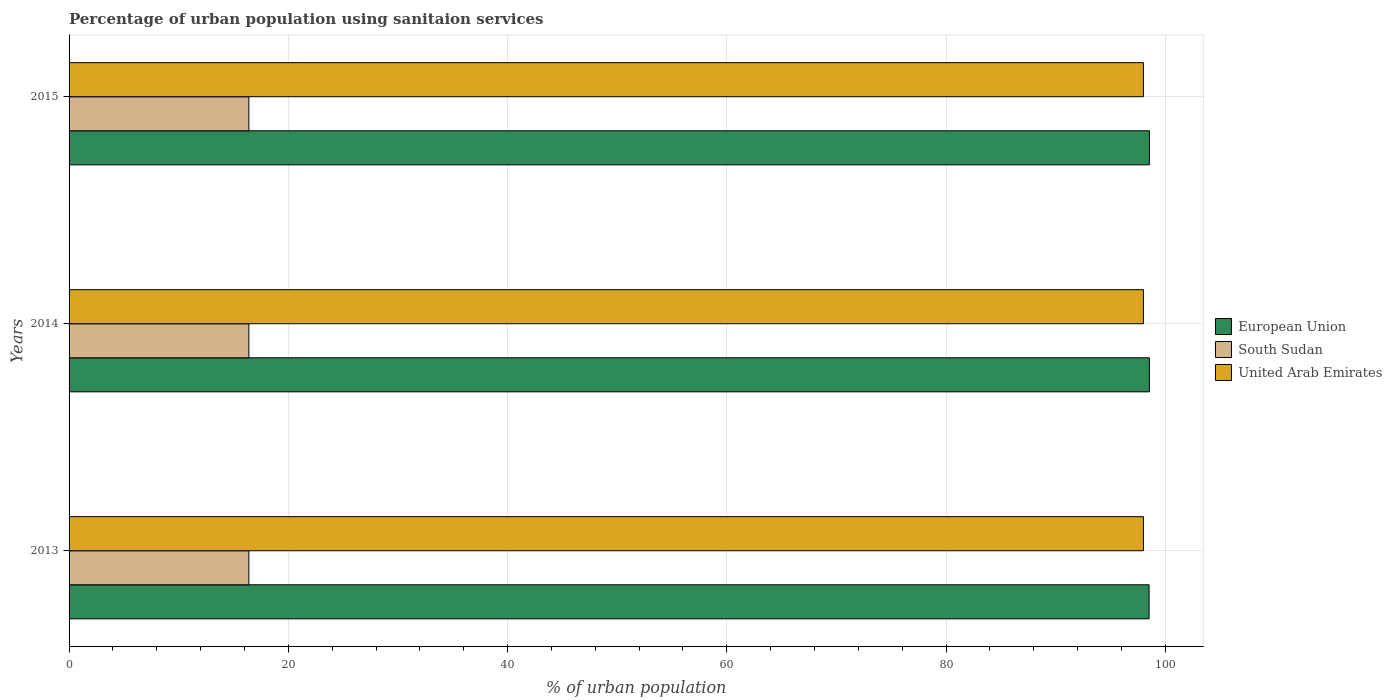Are the number of bars per tick equal to the number of legend labels?
Your answer should be very brief. Yes. Are the number of bars on each tick of the Y-axis equal?
Provide a succinct answer. Yes. What is the label of the 1st group of bars from the top?
Ensure brevity in your answer.  2015. In how many cases, is the number of bars for a given year not equal to the number of legend labels?
Your answer should be very brief. 0. What is the percentage of urban population using sanitaion services in European Union in 2014?
Your answer should be compact. 98.54. Across all years, what is the maximum percentage of urban population using sanitaion services in European Union?
Ensure brevity in your answer.  98.55. Across all years, what is the minimum percentage of urban population using sanitaion services in South Sudan?
Provide a succinct answer. 16.4. In which year was the percentage of urban population using sanitaion services in South Sudan maximum?
Offer a terse response. 2013. What is the total percentage of urban population using sanitaion services in South Sudan in the graph?
Your response must be concise. 49.2. What is the difference between the percentage of urban population using sanitaion services in European Union in 2013 and that in 2014?
Offer a terse response. -0.03. What is the difference between the percentage of urban population using sanitaion services in European Union in 2014 and the percentage of urban population using sanitaion services in United Arab Emirates in 2015?
Provide a short and direct response. 0.54. What is the average percentage of urban population using sanitaion services in European Union per year?
Provide a short and direct response. 98.54. In the year 2015, what is the difference between the percentage of urban population using sanitaion services in European Union and percentage of urban population using sanitaion services in United Arab Emirates?
Offer a terse response. 0.55. In how many years, is the percentage of urban population using sanitaion services in South Sudan greater than 80 %?
Offer a terse response. 0. What is the ratio of the percentage of urban population using sanitaion services in European Union in 2014 to that in 2015?
Ensure brevity in your answer.  1. Is the percentage of urban population using sanitaion services in European Union in 2013 less than that in 2015?
Your answer should be very brief. Yes. Is the difference between the percentage of urban population using sanitaion services in European Union in 2013 and 2014 greater than the difference between the percentage of urban population using sanitaion services in United Arab Emirates in 2013 and 2014?
Offer a very short reply. No. What is the difference between the highest and the lowest percentage of urban population using sanitaion services in United Arab Emirates?
Provide a short and direct response. 0. What does the 3rd bar from the top in 2013 represents?
Give a very brief answer. European Union. What does the 3rd bar from the bottom in 2013 represents?
Offer a terse response. United Arab Emirates. Is it the case that in every year, the sum of the percentage of urban population using sanitaion services in European Union and percentage of urban population using sanitaion services in South Sudan is greater than the percentage of urban population using sanitaion services in United Arab Emirates?
Offer a very short reply. Yes. How many bars are there?
Offer a terse response. 9. Are all the bars in the graph horizontal?
Your answer should be compact. Yes. How many years are there in the graph?
Ensure brevity in your answer.  3. Are the values on the major ticks of X-axis written in scientific E-notation?
Your response must be concise. No. How are the legend labels stacked?
Give a very brief answer. Vertical. What is the title of the graph?
Your answer should be compact. Percentage of urban population using sanitaion services. What is the label or title of the X-axis?
Make the answer very short. % of urban population. What is the % of urban population in European Union in 2013?
Give a very brief answer. 98.52. What is the % of urban population in South Sudan in 2013?
Ensure brevity in your answer.  16.4. What is the % of urban population of United Arab Emirates in 2013?
Provide a short and direct response. 98. What is the % of urban population in European Union in 2014?
Make the answer very short. 98.54. What is the % of urban population in South Sudan in 2014?
Your answer should be very brief. 16.4. What is the % of urban population of European Union in 2015?
Ensure brevity in your answer.  98.55. What is the % of urban population in South Sudan in 2015?
Your answer should be compact. 16.4. What is the % of urban population in United Arab Emirates in 2015?
Your answer should be very brief. 98. Across all years, what is the maximum % of urban population in European Union?
Offer a very short reply. 98.55. Across all years, what is the maximum % of urban population of United Arab Emirates?
Your answer should be very brief. 98. Across all years, what is the minimum % of urban population of European Union?
Make the answer very short. 98.52. What is the total % of urban population of European Union in the graph?
Give a very brief answer. 295.61. What is the total % of urban population of South Sudan in the graph?
Offer a very short reply. 49.2. What is the total % of urban population in United Arab Emirates in the graph?
Make the answer very short. 294. What is the difference between the % of urban population of European Union in 2013 and that in 2014?
Provide a short and direct response. -0.03. What is the difference between the % of urban population in European Union in 2013 and that in 2015?
Offer a terse response. -0.03. What is the difference between the % of urban population in United Arab Emirates in 2013 and that in 2015?
Keep it short and to the point. 0. What is the difference between the % of urban population in European Union in 2014 and that in 2015?
Give a very brief answer. -0. What is the difference between the % of urban population in United Arab Emirates in 2014 and that in 2015?
Keep it short and to the point. 0. What is the difference between the % of urban population in European Union in 2013 and the % of urban population in South Sudan in 2014?
Ensure brevity in your answer.  82.12. What is the difference between the % of urban population in European Union in 2013 and the % of urban population in United Arab Emirates in 2014?
Provide a succinct answer. 0.52. What is the difference between the % of urban population of South Sudan in 2013 and the % of urban population of United Arab Emirates in 2014?
Offer a terse response. -81.6. What is the difference between the % of urban population in European Union in 2013 and the % of urban population in South Sudan in 2015?
Provide a succinct answer. 82.12. What is the difference between the % of urban population in European Union in 2013 and the % of urban population in United Arab Emirates in 2015?
Your answer should be compact. 0.52. What is the difference between the % of urban population in South Sudan in 2013 and the % of urban population in United Arab Emirates in 2015?
Provide a short and direct response. -81.6. What is the difference between the % of urban population in European Union in 2014 and the % of urban population in South Sudan in 2015?
Provide a succinct answer. 82.14. What is the difference between the % of urban population in European Union in 2014 and the % of urban population in United Arab Emirates in 2015?
Ensure brevity in your answer.  0.54. What is the difference between the % of urban population of South Sudan in 2014 and the % of urban population of United Arab Emirates in 2015?
Offer a terse response. -81.6. What is the average % of urban population of European Union per year?
Offer a very short reply. 98.54. What is the average % of urban population of United Arab Emirates per year?
Your response must be concise. 98. In the year 2013, what is the difference between the % of urban population in European Union and % of urban population in South Sudan?
Provide a short and direct response. 82.12. In the year 2013, what is the difference between the % of urban population of European Union and % of urban population of United Arab Emirates?
Provide a short and direct response. 0.52. In the year 2013, what is the difference between the % of urban population in South Sudan and % of urban population in United Arab Emirates?
Make the answer very short. -81.6. In the year 2014, what is the difference between the % of urban population of European Union and % of urban population of South Sudan?
Offer a very short reply. 82.14. In the year 2014, what is the difference between the % of urban population in European Union and % of urban population in United Arab Emirates?
Provide a short and direct response. 0.54. In the year 2014, what is the difference between the % of urban population of South Sudan and % of urban population of United Arab Emirates?
Your answer should be very brief. -81.6. In the year 2015, what is the difference between the % of urban population in European Union and % of urban population in South Sudan?
Your answer should be very brief. 82.15. In the year 2015, what is the difference between the % of urban population of European Union and % of urban population of United Arab Emirates?
Ensure brevity in your answer.  0.55. In the year 2015, what is the difference between the % of urban population of South Sudan and % of urban population of United Arab Emirates?
Provide a short and direct response. -81.6. What is the ratio of the % of urban population in South Sudan in 2013 to that in 2014?
Give a very brief answer. 1. What is the ratio of the % of urban population in South Sudan in 2013 to that in 2015?
Provide a succinct answer. 1. What is the ratio of the % of urban population of United Arab Emirates in 2013 to that in 2015?
Provide a short and direct response. 1. What is the ratio of the % of urban population in South Sudan in 2014 to that in 2015?
Provide a short and direct response. 1. What is the difference between the highest and the second highest % of urban population in European Union?
Make the answer very short. 0. What is the difference between the highest and the second highest % of urban population in South Sudan?
Your answer should be very brief. 0. What is the difference between the highest and the lowest % of urban population in European Union?
Offer a very short reply. 0.03. 